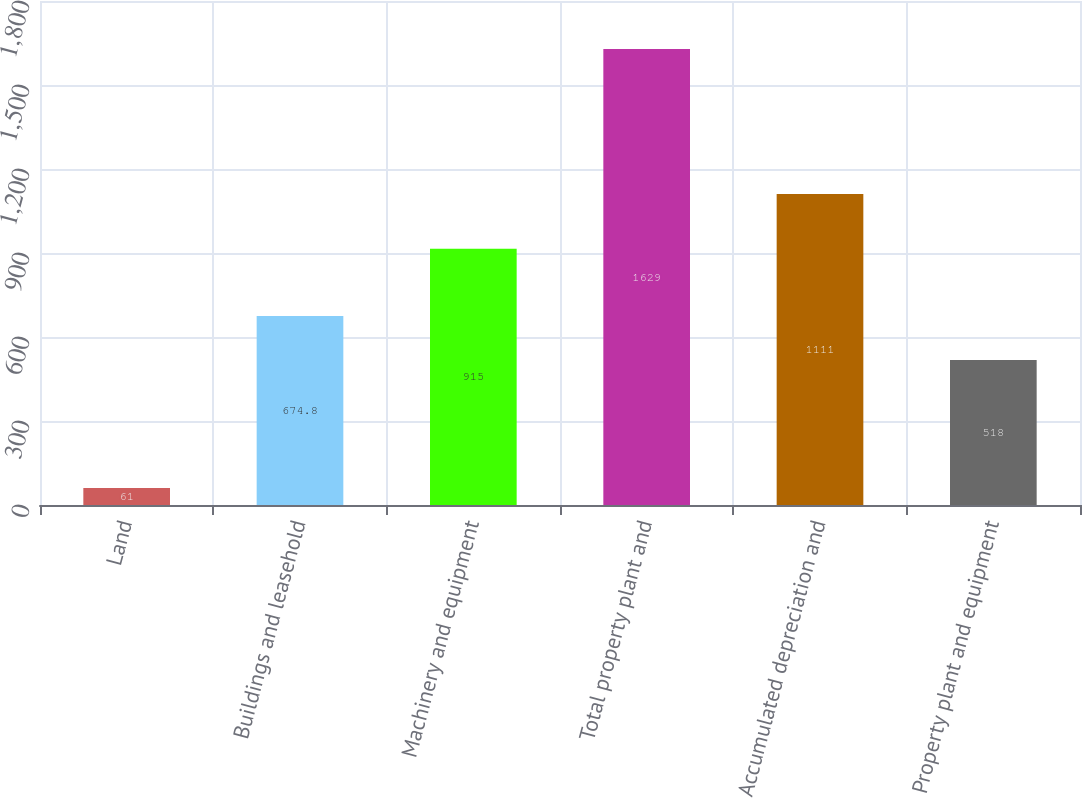Convert chart. <chart><loc_0><loc_0><loc_500><loc_500><bar_chart><fcel>Land<fcel>Buildings and leasehold<fcel>Machinery and equipment<fcel>Total property plant and<fcel>Accumulated depreciation and<fcel>Property plant and equipment<nl><fcel>61<fcel>674.8<fcel>915<fcel>1629<fcel>1111<fcel>518<nl></chart> 